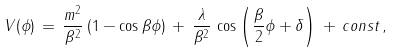Convert formula to latex. <formula><loc_0><loc_0><loc_500><loc_500>V ( \phi ) \, = \, \frac { m ^ { 2 } } { \beta ^ { 2 } } \, ( 1 - \cos \beta \phi ) \, + \, \frac { \lambda } { \beta ^ { 2 } } \, \cos \left ( \frac { \beta } { 2 } \phi + \delta \right ) \, + \, c o n s t \, ,</formula> 